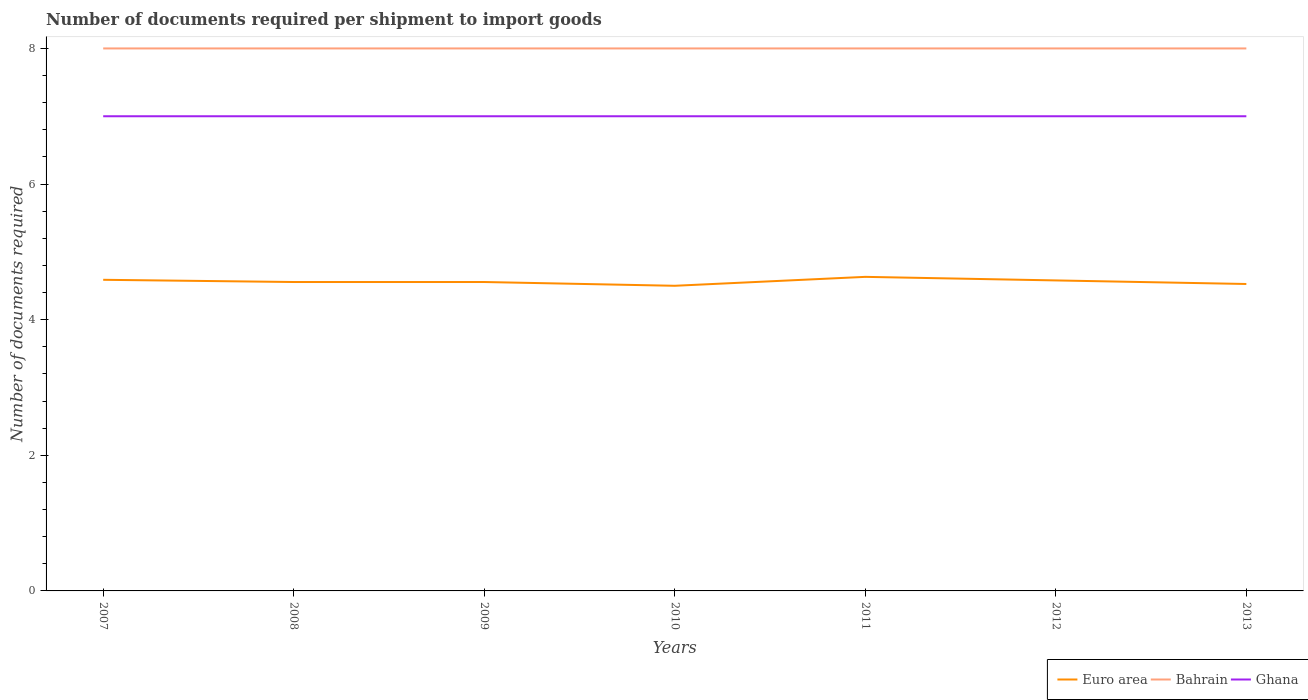How many different coloured lines are there?
Provide a succinct answer. 3. Is the number of lines equal to the number of legend labels?
Provide a succinct answer. Yes. Across all years, what is the maximum number of documents required per shipment to import goods in Bahrain?
Offer a very short reply. 8. What is the difference between the highest and the second highest number of documents required per shipment to import goods in Euro area?
Offer a very short reply. 0.13. What is the difference between the highest and the lowest number of documents required per shipment to import goods in Bahrain?
Give a very brief answer. 0. Is the number of documents required per shipment to import goods in Euro area strictly greater than the number of documents required per shipment to import goods in Bahrain over the years?
Offer a very short reply. Yes. Does the graph contain grids?
Give a very brief answer. No. Where does the legend appear in the graph?
Offer a very short reply. Bottom right. What is the title of the graph?
Ensure brevity in your answer.  Number of documents required per shipment to import goods. What is the label or title of the X-axis?
Your response must be concise. Years. What is the label or title of the Y-axis?
Offer a very short reply. Number of documents required. What is the Number of documents required of Euro area in 2007?
Provide a succinct answer. 4.59. What is the Number of documents required in Ghana in 2007?
Give a very brief answer. 7. What is the Number of documents required in Euro area in 2008?
Offer a terse response. 4.56. What is the Number of documents required in Bahrain in 2008?
Provide a short and direct response. 8. What is the Number of documents required of Ghana in 2008?
Provide a succinct answer. 7. What is the Number of documents required of Euro area in 2009?
Give a very brief answer. 4.56. What is the Number of documents required of Bahrain in 2009?
Your answer should be compact. 8. What is the Number of documents required in Bahrain in 2010?
Keep it short and to the point. 8. What is the Number of documents required of Euro area in 2011?
Your answer should be very brief. 4.63. What is the Number of documents required of Euro area in 2012?
Keep it short and to the point. 4.58. What is the Number of documents required in Ghana in 2012?
Ensure brevity in your answer.  7. What is the Number of documents required in Euro area in 2013?
Ensure brevity in your answer.  4.53. What is the Number of documents required of Bahrain in 2013?
Offer a terse response. 8. What is the Number of documents required of Ghana in 2013?
Ensure brevity in your answer.  7. Across all years, what is the maximum Number of documents required in Euro area?
Provide a short and direct response. 4.63. Across all years, what is the maximum Number of documents required of Ghana?
Make the answer very short. 7. Across all years, what is the minimum Number of documents required in Euro area?
Your answer should be very brief. 4.5. What is the total Number of documents required of Euro area in the graph?
Give a very brief answer. 31.94. What is the total Number of documents required in Bahrain in the graph?
Ensure brevity in your answer.  56. What is the difference between the Number of documents required in Euro area in 2007 and that in 2008?
Your answer should be very brief. 0.03. What is the difference between the Number of documents required of Ghana in 2007 and that in 2008?
Your response must be concise. 0. What is the difference between the Number of documents required in Euro area in 2007 and that in 2009?
Provide a succinct answer. 0.03. What is the difference between the Number of documents required in Bahrain in 2007 and that in 2009?
Provide a succinct answer. 0. What is the difference between the Number of documents required of Euro area in 2007 and that in 2010?
Provide a short and direct response. 0.09. What is the difference between the Number of documents required of Bahrain in 2007 and that in 2010?
Provide a short and direct response. 0. What is the difference between the Number of documents required in Euro area in 2007 and that in 2011?
Your response must be concise. -0.04. What is the difference between the Number of documents required in Euro area in 2007 and that in 2012?
Offer a very short reply. 0.01. What is the difference between the Number of documents required in Bahrain in 2007 and that in 2012?
Your answer should be very brief. 0. What is the difference between the Number of documents required in Ghana in 2007 and that in 2012?
Keep it short and to the point. 0. What is the difference between the Number of documents required in Euro area in 2007 and that in 2013?
Offer a terse response. 0.06. What is the difference between the Number of documents required in Bahrain in 2007 and that in 2013?
Offer a very short reply. 0. What is the difference between the Number of documents required in Euro area in 2008 and that in 2009?
Provide a succinct answer. 0. What is the difference between the Number of documents required in Ghana in 2008 and that in 2009?
Your response must be concise. 0. What is the difference between the Number of documents required of Euro area in 2008 and that in 2010?
Your answer should be compact. 0.06. What is the difference between the Number of documents required of Bahrain in 2008 and that in 2010?
Give a very brief answer. 0. What is the difference between the Number of documents required of Ghana in 2008 and that in 2010?
Provide a short and direct response. 0. What is the difference between the Number of documents required in Euro area in 2008 and that in 2011?
Your answer should be very brief. -0.08. What is the difference between the Number of documents required of Euro area in 2008 and that in 2012?
Offer a terse response. -0.02. What is the difference between the Number of documents required in Bahrain in 2008 and that in 2012?
Provide a succinct answer. 0. What is the difference between the Number of documents required of Euro area in 2008 and that in 2013?
Offer a terse response. 0.03. What is the difference between the Number of documents required of Bahrain in 2008 and that in 2013?
Your answer should be very brief. 0. What is the difference between the Number of documents required of Ghana in 2008 and that in 2013?
Your response must be concise. 0. What is the difference between the Number of documents required of Euro area in 2009 and that in 2010?
Offer a very short reply. 0.06. What is the difference between the Number of documents required of Euro area in 2009 and that in 2011?
Your answer should be compact. -0.08. What is the difference between the Number of documents required of Ghana in 2009 and that in 2011?
Ensure brevity in your answer.  0. What is the difference between the Number of documents required in Euro area in 2009 and that in 2012?
Make the answer very short. -0.02. What is the difference between the Number of documents required of Ghana in 2009 and that in 2012?
Offer a very short reply. 0. What is the difference between the Number of documents required of Euro area in 2009 and that in 2013?
Give a very brief answer. 0.03. What is the difference between the Number of documents required in Bahrain in 2009 and that in 2013?
Your answer should be compact. 0. What is the difference between the Number of documents required of Ghana in 2009 and that in 2013?
Provide a succinct answer. 0. What is the difference between the Number of documents required in Euro area in 2010 and that in 2011?
Offer a terse response. -0.13. What is the difference between the Number of documents required in Bahrain in 2010 and that in 2011?
Make the answer very short. 0. What is the difference between the Number of documents required of Ghana in 2010 and that in 2011?
Provide a succinct answer. 0. What is the difference between the Number of documents required of Euro area in 2010 and that in 2012?
Offer a very short reply. -0.08. What is the difference between the Number of documents required in Bahrain in 2010 and that in 2012?
Your answer should be compact. 0. What is the difference between the Number of documents required in Ghana in 2010 and that in 2012?
Make the answer very short. 0. What is the difference between the Number of documents required in Euro area in 2010 and that in 2013?
Ensure brevity in your answer.  -0.03. What is the difference between the Number of documents required of Euro area in 2011 and that in 2012?
Provide a short and direct response. 0.05. What is the difference between the Number of documents required in Bahrain in 2011 and that in 2012?
Ensure brevity in your answer.  0. What is the difference between the Number of documents required of Ghana in 2011 and that in 2012?
Provide a short and direct response. 0. What is the difference between the Number of documents required of Euro area in 2011 and that in 2013?
Your answer should be compact. 0.11. What is the difference between the Number of documents required of Euro area in 2012 and that in 2013?
Offer a terse response. 0.05. What is the difference between the Number of documents required in Euro area in 2007 and the Number of documents required in Bahrain in 2008?
Provide a short and direct response. -3.41. What is the difference between the Number of documents required of Euro area in 2007 and the Number of documents required of Ghana in 2008?
Make the answer very short. -2.41. What is the difference between the Number of documents required of Bahrain in 2007 and the Number of documents required of Ghana in 2008?
Ensure brevity in your answer.  1. What is the difference between the Number of documents required in Euro area in 2007 and the Number of documents required in Bahrain in 2009?
Provide a short and direct response. -3.41. What is the difference between the Number of documents required in Euro area in 2007 and the Number of documents required in Ghana in 2009?
Provide a short and direct response. -2.41. What is the difference between the Number of documents required in Bahrain in 2007 and the Number of documents required in Ghana in 2009?
Your response must be concise. 1. What is the difference between the Number of documents required in Euro area in 2007 and the Number of documents required in Bahrain in 2010?
Provide a short and direct response. -3.41. What is the difference between the Number of documents required of Euro area in 2007 and the Number of documents required of Ghana in 2010?
Give a very brief answer. -2.41. What is the difference between the Number of documents required of Bahrain in 2007 and the Number of documents required of Ghana in 2010?
Your answer should be compact. 1. What is the difference between the Number of documents required in Euro area in 2007 and the Number of documents required in Bahrain in 2011?
Your response must be concise. -3.41. What is the difference between the Number of documents required of Euro area in 2007 and the Number of documents required of Ghana in 2011?
Give a very brief answer. -2.41. What is the difference between the Number of documents required of Bahrain in 2007 and the Number of documents required of Ghana in 2011?
Provide a short and direct response. 1. What is the difference between the Number of documents required of Euro area in 2007 and the Number of documents required of Bahrain in 2012?
Ensure brevity in your answer.  -3.41. What is the difference between the Number of documents required of Euro area in 2007 and the Number of documents required of Ghana in 2012?
Ensure brevity in your answer.  -2.41. What is the difference between the Number of documents required of Euro area in 2007 and the Number of documents required of Bahrain in 2013?
Give a very brief answer. -3.41. What is the difference between the Number of documents required in Euro area in 2007 and the Number of documents required in Ghana in 2013?
Offer a terse response. -2.41. What is the difference between the Number of documents required in Bahrain in 2007 and the Number of documents required in Ghana in 2013?
Your answer should be very brief. 1. What is the difference between the Number of documents required in Euro area in 2008 and the Number of documents required in Bahrain in 2009?
Your answer should be very brief. -3.44. What is the difference between the Number of documents required of Euro area in 2008 and the Number of documents required of Ghana in 2009?
Keep it short and to the point. -2.44. What is the difference between the Number of documents required of Bahrain in 2008 and the Number of documents required of Ghana in 2009?
Give a very brief answer. 1. What is the difference between the Number of documents required of Euro area in 2008 and the Number of documents required of Bahrain in 2010?
Your response must be concise. -3.44. What is the difference between the Number of documents required of Euro area in 2008 and the Number of documents required of Ghana in 2010?
Your answer should be compact. -2.44. What is the difference between the Number of documents required in Euro area in 2008 and the Number of documents required in Bahrain in 2011?
Your answer should be very brief. -3.44. What is the difference between the Number of documents required in Euro area in 2008 and the Number of documents required in Ghana in 2011?
Ensure brevity in your answer.  -2.44. What is the difference between the Number of documents required of Euro area in 2008 and the Number of documents required of Bahrain in 2012?
Give a very brief answer. -3.44. What is the difference between the Number of documents required of Euro area in 2008 and the Number of documents required of Ghana in 2012?
Ensure brevity in your answer.  -2.44. What is the difference between the Number of documents required of Bahrain in 2008 and the Number of documents required of Ghana in 2012?
Offer a very short reply. 1. What is the difference between the Number of documents required of Euro area in 2008 and the Number of documents required of Bahrain in 2013?
Keep it short and to the point. -3.44. What is the difference between the Number of documents required in Euro area in 2008 and the Number of documents required in Ghana in 2013?
Offer a terse response. -2.44. What is the difference between the Number of documents required in Bahrain in 2008 and the Number of documents required in Ghana in 2013?
Ensure brevity in your answer.  1. What is the difference between the Number of documents required of Euro area in 2009 and the Number of documents required of Bahrain in 2010?
Provide a short and direct response. -3.44. What is the difference between the Number of documents required in Euro area in 2009 and the Number of documents required in Ghana in 2010?
Make the answer very short. -2.44. What is the difference between the Number of documents required in Bahrain in 2009 and the Number of documents required in Ghana in 2010?
Keep it short and to the point. 1. What is the difference between the Number of documents required of Euro area in 2009 and the Number of documents required of Bahrain in 2011?
Keep it short and to the point. -3.44. What is the difference between the Number of documents required in Euro area in 2009 and the Number of documents required in Ghana in 2011?
Offer a terse response. -2.44. What is the difference between the Number of documents required in Bahrain in 2009 and the Number of documents required in Ghana in 2011?
Your answer should be compact. 1. What is the difference between the Number of documents required of Euro area in 2009 and the Number of documents required of Bahrain in 2012?
Offer a very short reply. -3.44. What is the difference between the Number of documents required in Euro area in 2009 and the Number of documents required in Ghana in 2012?
Make the answer very short. -2.44. What is the difference between the Number of documents required of Bahrain in 2009 and the Number of documents required of Ghana in 2012?
Your answer should be compact. 1. What is the difference between the Number of documents required in Euro area in 2009 and the Number of documents required in Bahrain in 2013?
Keep it short and to the point. -3.44. What is the difference between the Number of documents required in Euro area in 2009 and the Number of documents required in Ghana in 2013?
Keep it short and to the point. -2.44. What is the difference between the Number of documents required in Euro area in 2010 and the Number of documents required in Bahrain in 2011?
Offer a terse response. -3.5. What is the difference between the Number of documents required in Bahrain in 2010 and the Number of documents required in Ghana in 2011?
Ensure brevity in your answer.  1. What is the difference between the Number of documents required in Bahrain in 2010 and the Number of documents required in Ghana in 2012?
Ensure brevity in your answer.  1. What is the difference between the Number of documents required in Euro area in 2010 and the Number of documents required in Ghana in 2013?
Offer a terse response. -2.5. What is the difference between the Number of documents required in Bahrain in 2010 and the Number of documents required in Ghana in 2013?
Make the answer very short. 1. What is the difference between the Number of documents required of Euro area in 2011 and the Number of documents required of Bahrain in 2012?
Provide a short and direct response. -3.37. What is the difference between the Number of documents required of Euro area in 2011 and the Number of documents required of Ghana in 2012?
Make the answer very short. -2.37. What is the difference between the Number of documents required of Euro area in 2011 and the Number of documents required of Bahrain in 2013?
Your answer should be very brief. -3.37. What is the difference between the Number of documents required of Euro area in 2011 and the Number of documents required of Ghana in 2013?
Provide a short and direct response. -2.37. What is the difference between the Number of documents required of Euro area in 2012 and the Number of documents required of Bahrain in 2013?
Offer a terse response. -3.42. What is the difference between the Number of documents required of Euro area in 2012 and the Number of documents required of Ghana in 2013?
Your answer should be compact. -2.42. What is the difference between the Number of documents required in Bahrain in 2012 and the Number of documents required in Ghana in 2013?
Your response must be concise. 1. What is the average Number of documents required of Euro area per year?
Make the answer very short. 4.56. What is the average Number of documents required of Ghana per year?
Your answer should be very brief. 7. In the year 2007, what is the difference between the Number of documents required of Euro area and Number of documents required of Bahrain?
Provide a succinct answer. -3.41. In the year 2007, what is the difference between the Number of documents required in Euro area and Number of documents required in Ghana?
Give a very brief answer. -2.41. In the year 2007, what is the difference between the Number of documents required of Bahrain and Number of documents required of Ghana?
Provide a succinct answer. 1. In the year 2008, what is the difference between the Number of documents required in Euro area and Number of documents required in Bahrain?
Your answer should be compact. -3.44. In the year 2008, what is the difference between the Number of documents required of Euro area and Number of documents required of Ghana?
Keep it short and to the point. -2.44. In the year 2009, what is the difference between the Number of documents required of Euro area and Number of documents required of Bahrain?
Offer a terse response. -3.44. In the year 2009, what is the difference between the Number of documents required of Euro area and Number of documents required of Ghana?
Make the answer very short. -2.44. In the year 2009, what is the difference between the Number of documents required in Bahrain and Number of documents required in Ghana?
Offer a very short reply. 1. In the year 2010, what is the difference between the Number of documents required in Euro area and Number of documents required in Ghana?
Ensure brevity in your answer.  -2.5. In the year 2010, what is the difference between the Number of documents required of Bahrain and Number of documents required of Ghana?
Your answer should be very brief. 1. In the year 2011, what is the difference between the Number of documents required in Euro area and Number of documents required in Bahrain?
Provide a short and direct response. -3.37. In the year 2011, what is the difference between the Number of documents required of Euro area and Number of documents required of Ghana?
Your answer should be compact. -2.37. In the year 2011, what is the difference between the Number of documents required of Bahrain and Number of documents required of Ghana?
Give a very brief answer. 1. In the year 2012, what is the difference between the Number of documents required of Euro area and Number of documents required of Bahrain?
Make the answer very short. -3.42. In the year 2012, what is the difference between the Number of documents required in Euro area and Number of documents required in Ghana?
Provide a succinct answer. -2.42. In the year 2013, what is the difference between the Number of documents required in Euro area and Number of documents required in Bahrain?
Your response must be concise. -3.47. In the year 2013, what is the difference between the Number of documents required of Euro area and Number of documents required of Ghana?
Your answer should be compact. -2.47. What is the ratio of the Number of documents required in Euro area in 2007 to that in 2008?
Offer a very short reply. 1.01. What is the ratio of the Number of documents required in Ghana in 2007 to that in 2008?
Make the answer very short. 1. What is the ratio of the Number of documents required of Bahrain in 2007 to that in 2009?
Your response must be concise. 1. What is the ratio of the Number of documents required in Euro area in 2007 to that in 2010?
Provide a succinct answer. 1.02. What is the ratio of the Number of documents required in Euro area in 2007 to that in 2011?
Offer a terse response. 0.99. What is the ratio of the Number of documents required of Bahrain in 2007 to that in 2011?
Make the answer very short. 1. What is the ratio of the Number of documents required in Ghana in 2007 to that in 2011?
Your answer should be compact. 1. What is the ratio of the Number of documents required of Euro area in 2007 to that in 2012?
Offer a terse response. 1. What is the ratio of the Number of documents required of Bahrain in 2007 to that in 2012?
Provide a succinct answer. 1. What is the ratio of the Number of documents required in Ghana in 2007 to that in 2012?
Keep it short and to the point. 1. What is the ratio of the Number of documents required of Euro area in 2007 to that in 2013?
Your answer should be compact. 1.01. What is the ratio of the Number of documents required of Ghana in 2007 to that in 2013?
Provide a short and direct response. 1. What is the ratio of the Number of documents required in Euro area in 2008 to that in 2009?
Offer a very short reply. 1. What is the ratio of the Number of documents required of Bahrain in 2008 to that in 2009?
Keep it short and to the point. 1. What is the ratio of the Number of documents required in Euro area in 2008 to that in 2010?
Make the answer very short. 1.01. What is the ratio of the Number of documents required in Euro area in 2008 to that in 2011?
Your response must be concise. 0.98. What is the ratio of the Number of documents required of Bahrain in 2008 to that in 2012?
Provide a succinct answer. 1. What is the ratio of the Number of documents required in Euro area in 2008 to that in 2013?
Ensure brevity in your answer.  1.01. What is the ratio of the Number of documents required in Bahrain in 2008 to that in 2013?
Make the answer very short. 1. What is the ratio of the Number of documents required in Ghana in 2008 to that in 2013?
Offer a very short reply. 1. What is the ratio of the Number of documents required in Euro area in 2009 to that in 2010?
Give a very brief answer. 1.01. What is the ratio of the Number of documents required of Euro area in 2009 to that in 2011?
Your answer should be very brief. 0.98. What is the ratio of the Number of documents required in Ghana in 2009 to that in 2011?
Your response must be concise. 1. What is the ratio of the Number of documents required of Euro area in 2009 to that in 2012?
Your answer should be compact. 0.99. What is the ratio of the Number of documents required in Bahrain in 2009 to that in 2012?
Your answer should be compact. 1. What is the ratio of the Number of documents required of Euro area in 2009 to that in 2013?
Provide a short and direct response. 1.01. What is the ratio of the Number of documents required in Bahrain in 2009 to that in 2013?
Your answer should be compact. 1. What is the ratio of the Number of documents required in Euro area in 2010 to that in 2011?
Provide a short and direct response. 0.97. What is the ratio of the Number of documents required of Euro area in 2010 to that in 2012?
Your answer should be compact. 0.98. What is the ratio of the Number of documents required in Euro area in 2010 to that in 2013?
Keep it short and to the point. 0.99. What is the ratio of the Number of documents required in Ghana in 2010 to that in 2013?
Keep it short and to the point. 1. What is the ratio of the Number of documents required of Euro area in 2011 to that in 2012?
Your response must be concise. 1.01. What is the ratio of the Number of documents required in Euro area in 2011 to that in 2013?
Your response must be concise. 1.02. What is the ratio of the Number of documents required of Ghana in 2011 to that in 2013?
Your answer should be compact. 1. What is the ratio of the Number of documents required in Euro area in 2012 to that in 2013?
Keep it short and to the point. 1.01. What is the difference between the highest and the second highest Number of documents required of Euro area?
Keep it short and to the point. 0.04. What is the difference between the highest and the lowest Number of documents required of Euro area?
Ensure brevity in your answer.  0.13. What is the difference between the highest and the lowest Number of documents required of Ghana?
Give a very brief answer. 0. 